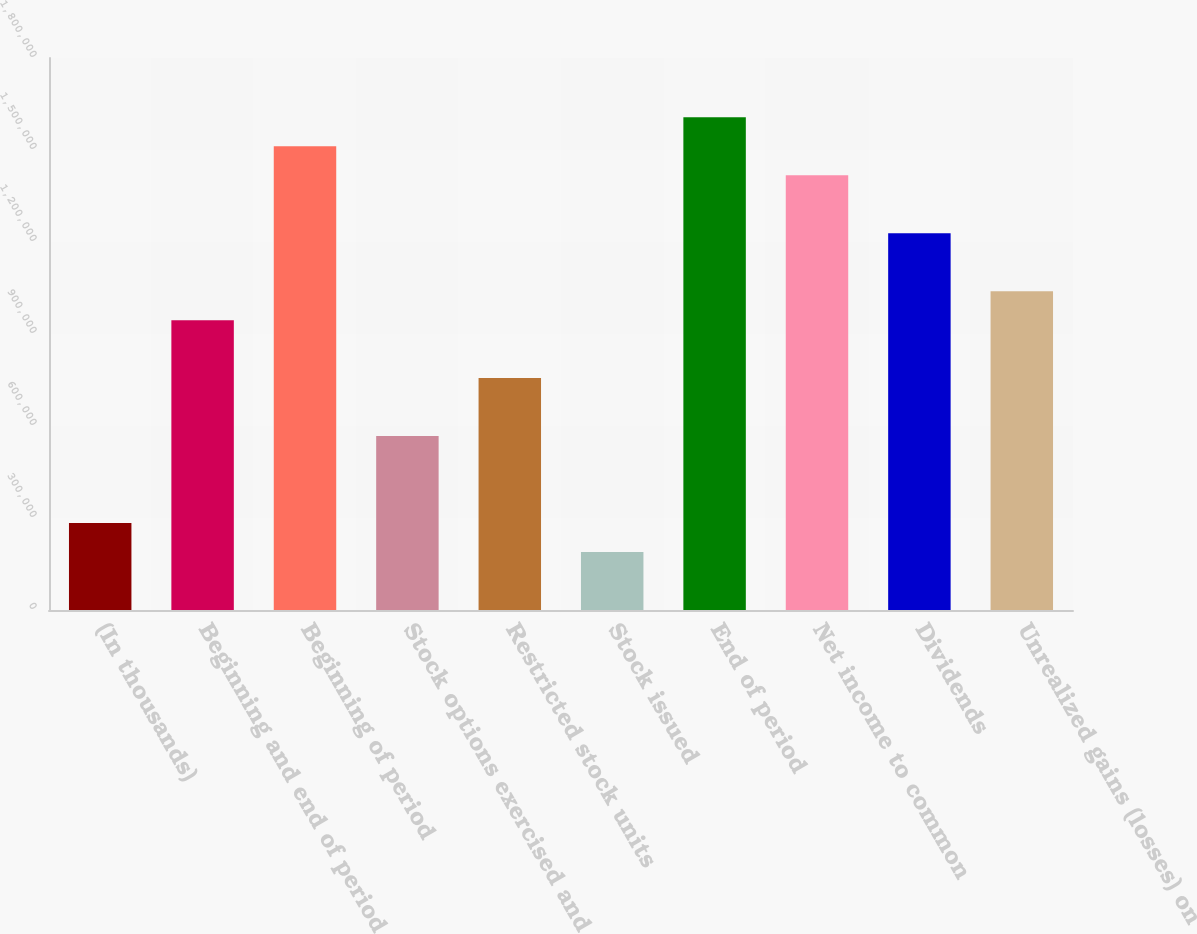Convert chart. <chart><loc_0><loc_0><loc_500><loc_500><bar_chart><fcel>(In thousands)<fcel>Beginning and end of period<fcel>Beginning of period<fcel>Stock options exercised and<fcel>Restricted stock units<fcel>Stock issued<fcel>End of period<fcel>Net income to common<fcel>Dividends<fcel>Unrealized gains (losses) on<nl><fcel>283586<fcel>945166<fcel>1.51224e+06<fcel>567120<fcel>756143<fcel>189074<fcel>1.60675e+06<fcel>1.41772e+06<fcel>1.2287e+06<fcel>1.03968e+06<nl></chart> 